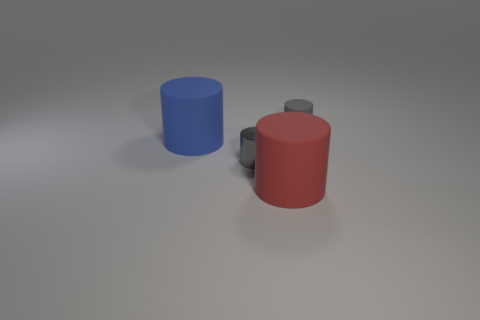The thing that is the same size as the blue matte cylinder is what color?
Your answer should be very brief. Red. What number of matte things are cylinders or big things?
Provide a short and direct response. 3. There is a rubber cylinder that is right of the big red thing; what number of gray metallic cylinders are left of it?
Ensure brevity in your answer.  1. What is the size of the cylinder that is the same color as the tiny metallic object?
Make the answer very short. Small. How many things are purple rubber blocks or matte cylinders that are behind the big red rubber cylinder?
Give a very brief answer. 2. Is there a big yellow object made of the same material as the red object?
Keep it short and to the point. No. What number of cylinders are both on the right side of the large blue object and on the left side of the red rubber cylinder?
Your answer should be very brief. 1. What material is the gray cylinder that is in front of the blue matte cylinder?
Your answer should be compact. Metal. The gray cylinder that is the same material as the big blue thing is what size?
Provide a short and direct response. Small. There is a shiny thing; are there any large red cylinders to the left of it?
Your response must be concise. No. 